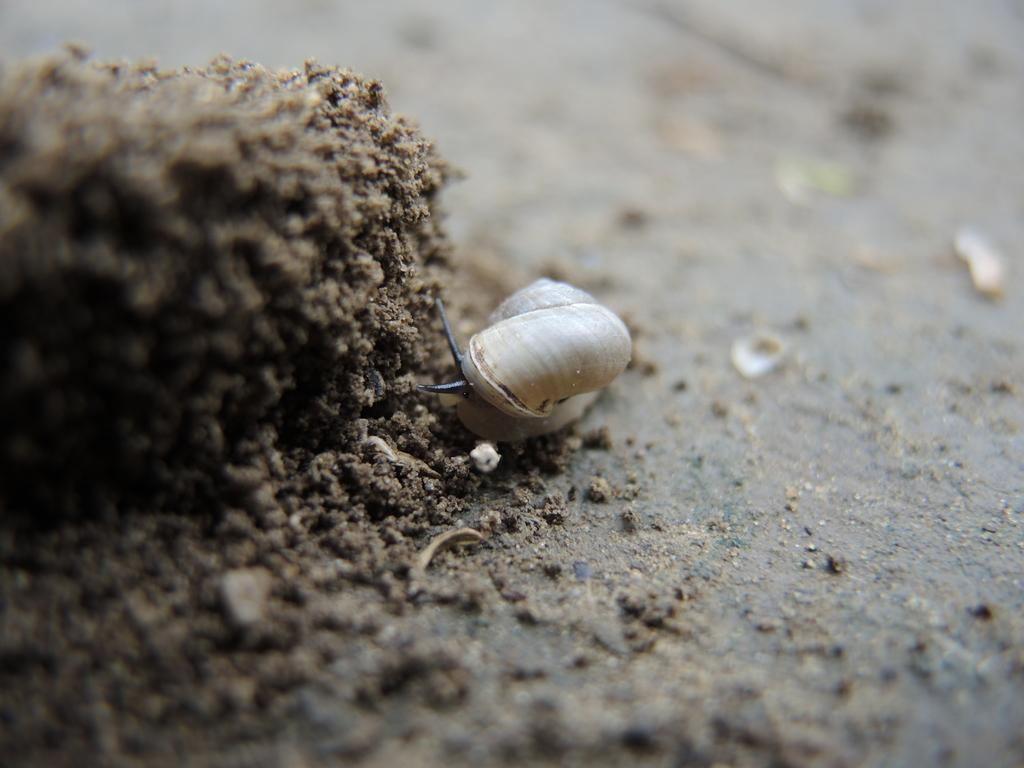What type of creature is present in the image? There is an insect in the image. Can you describe the color pattern of the insect? The insect has white and black color. What type of map is the insect using in the image? There is no map present in the image, as it features an insect with a white and black color pattern. Is the insect wearing a scarf in the image? There is no scarf present in the image, as it features an insect with a white and black color pattern. 